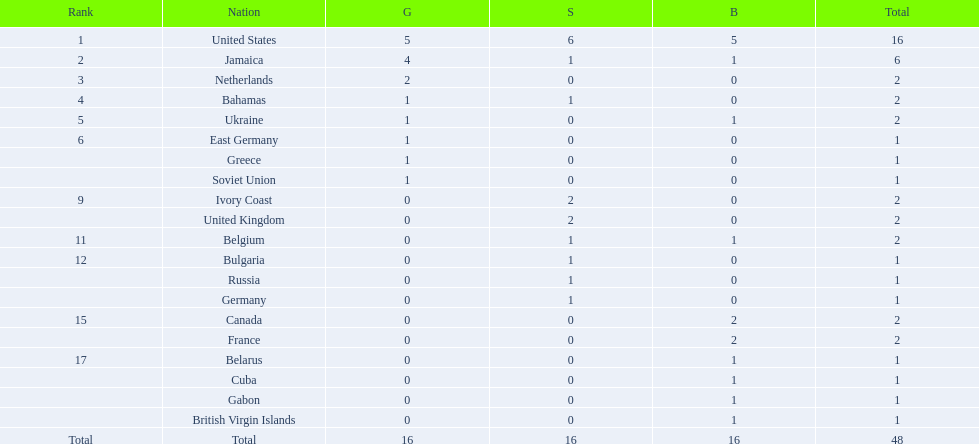What country won more gold medals than any other? United States. 